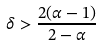<formula> <loc_0><loc_0><loc_500><loc_500>\delta > \frac { 2 ( \alpha - 1 ) } { 2 - \alpha }</formula> 